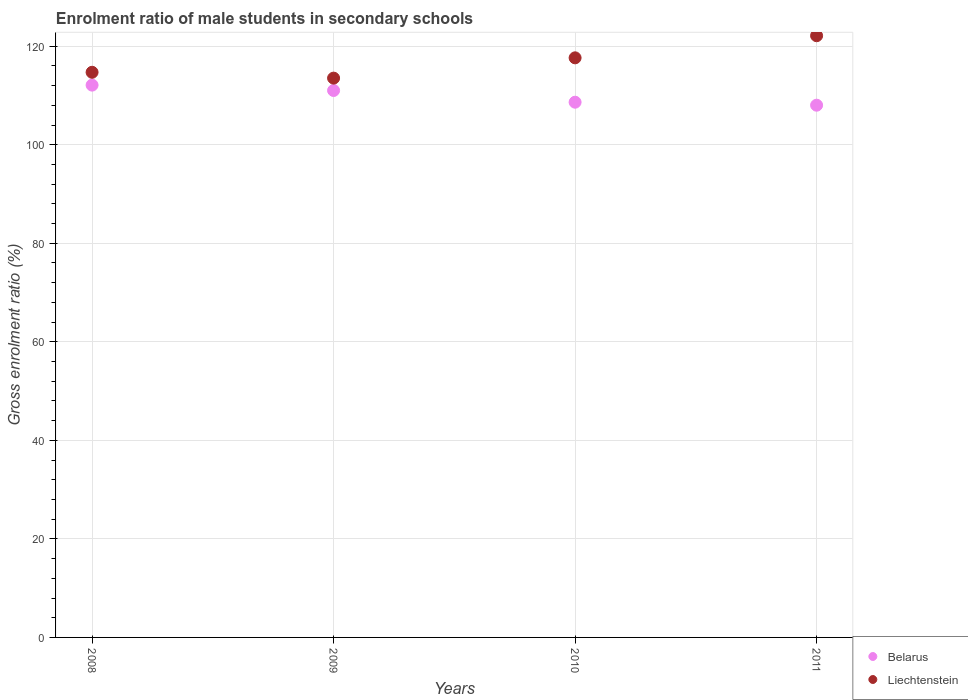What is the enrolment ratio of male students in secondary schools in Liechtenstein in 2011?
Offer a terse response. 122.12. Across all years, what is the maximum enrolment ratio of male students in secondary schools in Liechtenstein?
Provide a short and direct response. 122.12. Across all years, what is the minimum enrolment ratio of male students in secondary schools in Liechtenstein?
Give a very brief answer. 113.52. In which year was the enrolment ratio of male students in secondary schools in Liechtenstein minimum?
Give a very brief answer. 2009. What is the total enrolment ratio of male students in secondary schools in Belarus in the graph?
Offer a terse response. 439.76. What is the difference between the enrolment ratio of male students in secondary schools in Liechtenstein in 2008 and that in 2011?
Your answer should be compact. -7.42. What is the difference between the enrolment ratio of male students in secondary schools in Liechtenstein in 2008 and the enrolment ratio of male students in secondary schools in Belarus in 2009?
Offer a very short reply. 3.69. What is the average enrolment ratio of male students in secondary schools in Liechtenstein per year?
Make the answer very short. 116.99. In the year 2009, what is the difference between the enrolment ratio of male students in secondary schools in Belarus and enrolment ratio of male students in secondary schools in Liechtenstein?
Keep it short and to the point. -2.51. In how many years, is the enrolment ratio of male students in secondary schools in Belarus greater than 52 %?
Your answer should be compact. 4. What is the ratio of the enrolment ratio of male students in secondary schools in Belarus in 2008 to that in 2010?
Give a very brief answer. 1.03. What is the difference between the highest and the second highest enrolment ratio of male students in secondary schools in Liechtenstein?
Keep it short and to the point. 4.49. What is the difference between the highest and the lowest enrolment ratio of male students in secondary schools in Belarus?
Provide a short and direct response. 4.08. In how many years, is the enrolment ratio of male students in secondary schools in Liechtenstein greater than the average enrolment ratio of male students in secondary schools in Liechtenstein taken over all years?
Ensure brevity in your answer.  2. Is the sum of the enrolment ratio of male students in secondary schools in Belarus in 2010 and 2011 greater than the maximum enrolment ratio of male students in secondary schools in Liechtenstein across all years?
Your answer should be compact. Yes. Does the enrolment ratio of male students in secondary schools in Belarus monotonically increase over the years?
Offer a very short reply. No. How many dotlines are there?
Ensure brevity in your answer.  2. How many years are there in the graph?
Your response must be concise. 4. Does the graph contain any zero values?
Provide a short and direct response. No. What is the title of the graph?
Offer a very short reply. Enrolment ratio of male students in secondary schools. Does "Zambia" appear as one of the legend labels in the graph?
Make the answer very short. No. What is the label or title of the X-axis?
Offer a terse response. Years. What is the Gross enrolment ratio (%) of Belarus in 2008?
Provide a succinct answer. 112.1. What is the Gross enrolment ratio (%) of Liechtenstein in 2008?
Your answer should be compact. 114.7. What is the Gross enrolment ratio (%) of Belarus in 2009?
Ensure brevity in your answer.  111.01. What is the Gross enrolment ratio (%) of Liechtenstein in 2009?
Your answer should be very brief. 113.52. What is the Gross enrolment ratio (%) of Belarus in 2010?
Your answer should be compact. 108.63. What is the Gross enrolment ratio (%) in Liechtenstein in 2010?
Your answer should be compact. 117.64. What is the Gross enrolment ratio (%) in Belarus in 2011?
Ensure brevity in your answer.  108.02. What is the Gross enrolment ratio (%) of Liechtenstein in 2011?
Your answer should be compact. 122.12. Across all years, what is the maximum Gross enrolment ratio (%) of Belarus?
Your answer should be compact. 112.1. Across all years, what is the maximum Gross enrolment ratio (%) of Liechtenstein?
Your response must be concise. 122.12. Across all years, what is the minimum Gross enrolment ratio (%) in Belarus?
Provide a short and direct response. 108.02. Across all years, what is the minimum Gross enrolment ratio (%) of Liechtenstein?
Offer a very short reply. 113.52. What is the total Gross enrolment ratio (%) in Belarus in the graph?
Your answer should be very brief. 439.76. What is the total Gross enrolment ratio (%) in Liechtenstein in the graph?
Your answer should be very brief. 467.98. What is the difference between the Gross enrolment ratio (%) in Liechtenstein in 2008 and that in 2009?
Give a very brief answer. 1.18. What is the difference between the Gross enrolment ratio (%) in Belarus in 2008 and that in 2010?
Ensure brevity in your answer.  3.47. What is the difference between the Gross enrolment ratio (%) in Liechtenstein in 2008 and that in 2010?
Keep it short and to the point. -2.93. What is the difference between the Gross enrolment ratio (%) of Belarus in 2008 and that in 2011?
Give a very brief answer. 4.08. What is the difference between the Gross enrolment ratio (%) in Liechtenstein in 2008 and that in 2011?
Give a very brief answer. -7.42. What is the difference between the Gross enrolment ratio (%) of Belarus in 2009 and that in 2010?
Provide a succinct answer. 2.38. What is the difference between the Gross enrolment ratio (%) of Liechtenstein in 2009 and that in 2010?
Your response must be concise. -4.12. What is the difference between the Gross enrolment ratio (%) in Belarus in 2009 and that in 2011?
Offer a very short reply. 2.98. What is the difference between the Gross enrolment ratio (%) of Liechtenstein in 2009 and that in 2011?
Your answer should be very brief. -8.61. What is the difference between the Gross enrolment ratio (%) in Belarus in 2010 and that in 2011?
Make the answer very short. 0.61. What is the difference between the Gross enrolment ratio (%) of Liechtenstein in 2010 and that in 2011?
Ensure brevity in your answer.  -4.49. What is the difference between the Gross enrolment ratio (%) in Belarus in 2008 and the Gross enrolment ratio (%) in Liechtenstein in 2009?
Your answer should be compact. -1.42. What is the difference between the Gross enrolment ratio (%) of Belarus in 2008 and the Gross enrolment ratio (%) of Liechtenstein in 2010?
Make the answer very short. -5.54. What is the difference between the Gross enrolment ratio (%) of Belarus in 2008 and the Gross enrolment ratio (%) of Liechtenstein in 2011?
Your answer should be very brief. -10.02. What is the difference between the Gross enrolment ratio (%) in Belarus in 2009 and the Gross enrolment ratio (%) in Liechtenstein in 2010?
Offer a very short reply. -6.63. What is the difference between the Gross enrolment ratio (%) in Belarus in 2009 and the Gross enrolment ratio (%) in Liechtenstein in 2011?
Ensure brevity in your answer.  -11.12. What is the difference between the Gross enrolment ratio (%) of Belarus in 2010 and the Gross enrolment ratio (%) of Liechtenstein in 2011?
Offer a terse response. -13.49. What is the average Gross enrolment ratio (%) of Belarus per year?
Provide a short and direct response. 109.94. What is the average Gross enrolment ratio (%) in Liechtenstein per year?
Provide a succinct answer. 116.99. In the year 2008, what is the difference between the Gross enrolment ratio (%) in Belarus and Gross enrolment ratio (%) in Liechtenstein?
Keep it short and to the point. -2.6. In the year 2009, what is the difference between the Gross enrolment ratio (%) of Belarus and Gross enrolment ratio (%) of Liechtenstein?
Keep it short and to the point. -2.51. In the year 2010, what is the difference between the Gross enrolment ratio (%) in Belarus and Gross enrolment ratio (%) in Liechtenstein?
Keep it short and to the point. -9.01. In the year 2011, what is the difference between the Gross enrolment ratio (%) in Belarus and Gross enrolment ratio (%) in Liechtenstein?
Keep it short and to the point. -14.1. What is the ratio of the Gross enrolment ratio (%) in Belarus in 2008 to that in 2009?
Make the answer very short. 1.01. What is the ratio of the Gross enrolment ratio (%) of Liechtenstein in 2008 to that in 2009?
Your answer should be compact. 1.01. What is the ratio of the Gross enrolment ratio (%) in Belarus in 2008 to that in 2010?
Your answer should be very brief. 1.03. What is the ratio of the Gross enrolment ratio (%) in Liechtenstein in 2008 to that in 2010?
Offer a very short reply. 0.98. What is the ratio of the Gross enrolment ratio (%) of Belarus in 2008 to that in 2011?
Your answer should be very brief. 1.04. What is the ratio of the Gross enrolment ratio (%) in Liechtenstein in 2008 to that in 2011?
Your answer should be very brief. 0.94. What is the ratio of the Gross enrolment ratio (%) in Belarus in 2009 to that in 2010?
Give a very brief answer. 1.02. What is the ratio of the Gross enrolment ratio (%) of Belarus in 2009 to that in 2011?
Ensure brevity in your answer.  1.03. What is the ratio of the Gross enrolment ratio (%) of Liechtenstein in 2009 to that in 2011?
Provide a succinct answer. 0.93. What is the ratio of the Gross enrolment ratio (%) of Belarus in 2010 to that in 2011?
Ensure brevity in your answer.  1.01. What is the ratio of the Gross enrolment ratio (%) in Liechtenstein in 2010 to that in 2011?
Provide a succinct answer. 0.96. What is the difference between the highest and the second highest Gross enrolment ratio (%) of Liechtenstein?
Offer a very short reply. 4.49. What is the difference between the highest and the lowest Gross enrolment ratio (%) in Belarus?
Make the answer very short. 4.08. What is the difference between the highest and the lowest Gross enrolment ratio (%) of Liechtenstein?
Your response must be concise. 8.61. 